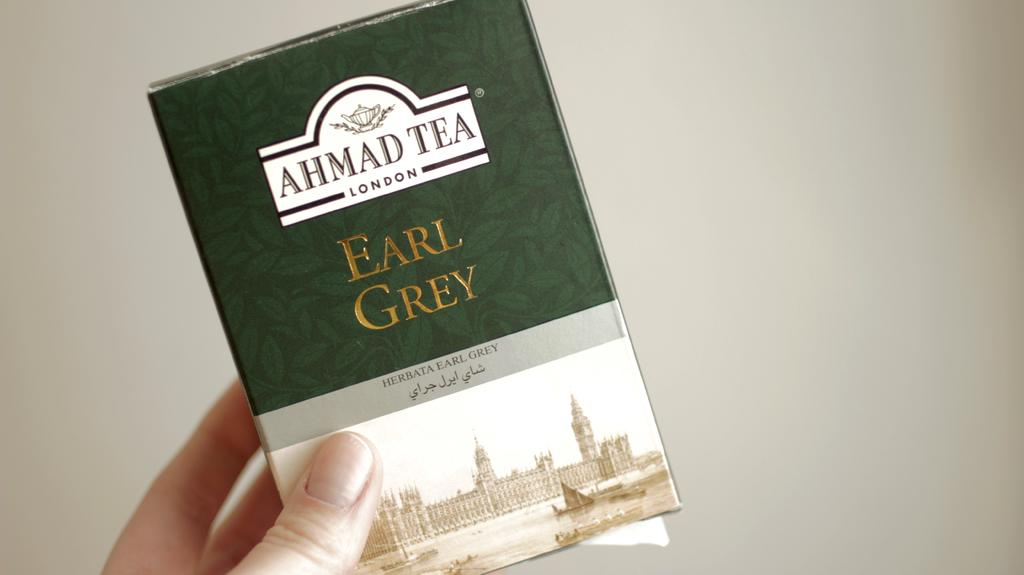<image>
Give a short and clear explanation of the subsequent image. A box of Earl Grey tea from Ahmad Tea of London. 